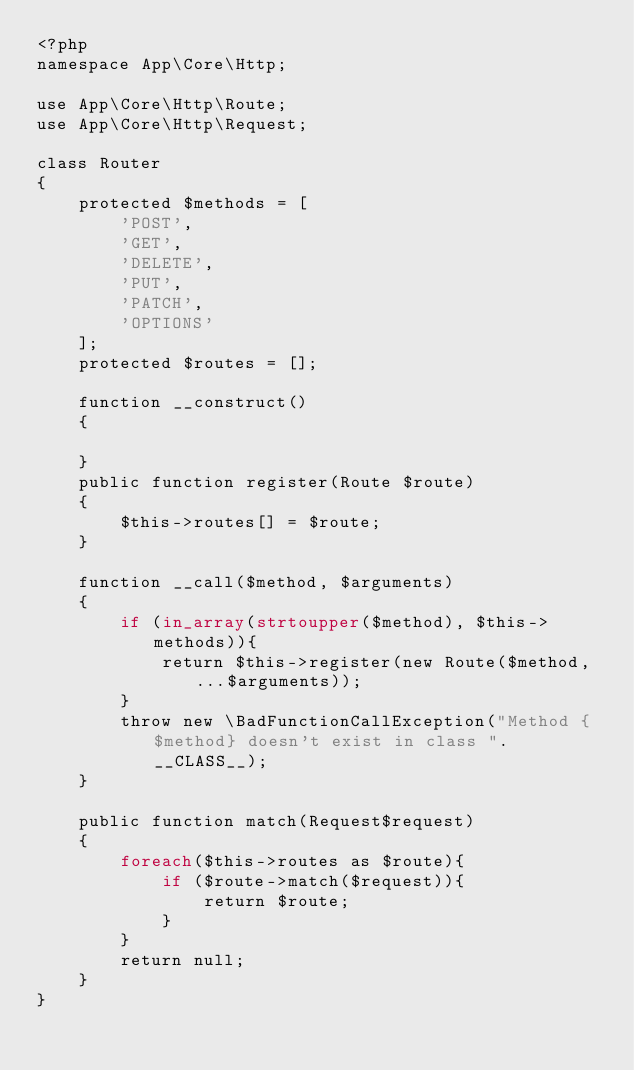<code> <loc_0><loc_0><loc_500><loc_500><_PHP_><?php
namespace App\Core\Http;

use App\Core\Http\Route;
use App\Core\Http\Request;

class Router
{
    protected $methods = [
        'POST',
        'GET',
        'DELETE',
        'PUT',
        'PATCH',
        'OPTIONS'
    ];
    protected $routes = [];
    
    function __construct()
    {
        
    }
    public function register(Route $route)
    {
        $this->routes[] = $route;
    }

    function __call($method, $arguments)
    {
        if (in_array(strtoupper($method), $this->methods)){
            return $this->register(new Route($method, ...$arguments));
        }
        throw new \BadFunctionCallException("Method {$method} doesn't exist in class ". __CLASS__);
    }

    public function match(Request$request)
    {
        foreach($this->routes as $route){
            if ($route->match($request)){
                return $route;
            }
        }
        return null;
    }
}
</code> 